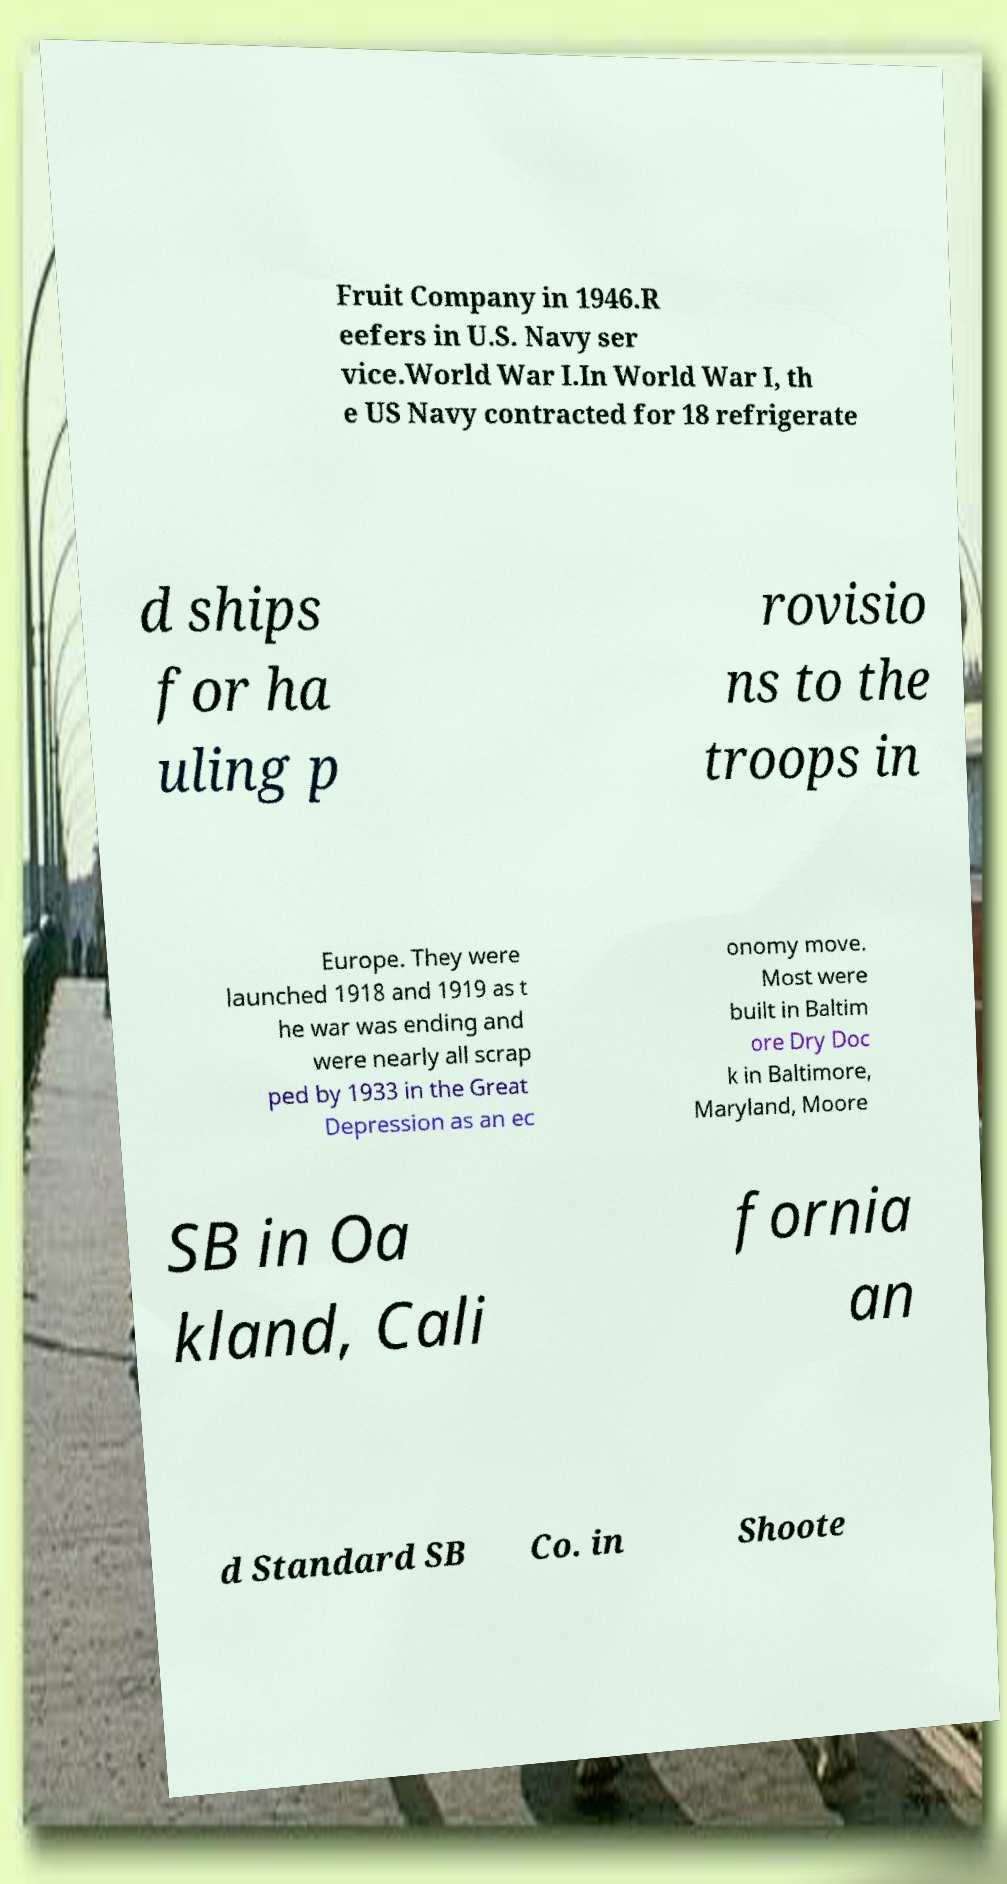Could you assist in decoding the text presented in this image and type it out clearly? Fruit Company in 1946.R eefers in U.S. Navy ser vice.World War I.In World War I, th e US Navy contracted for 18 refrigerate d ships for ha uling p rovisio ns to the troops in Europe. They were launched 1918 and 1919 as t he war was ending and were nearly all scrap ped by 1933 in the Great Depression as an ec onomy move. Most were built in Baltim ore Dry Doc k in Baltimore, Maryland, Moore SB in Oa kland, Cali fornia an d Standard SB Co. in Shoote 